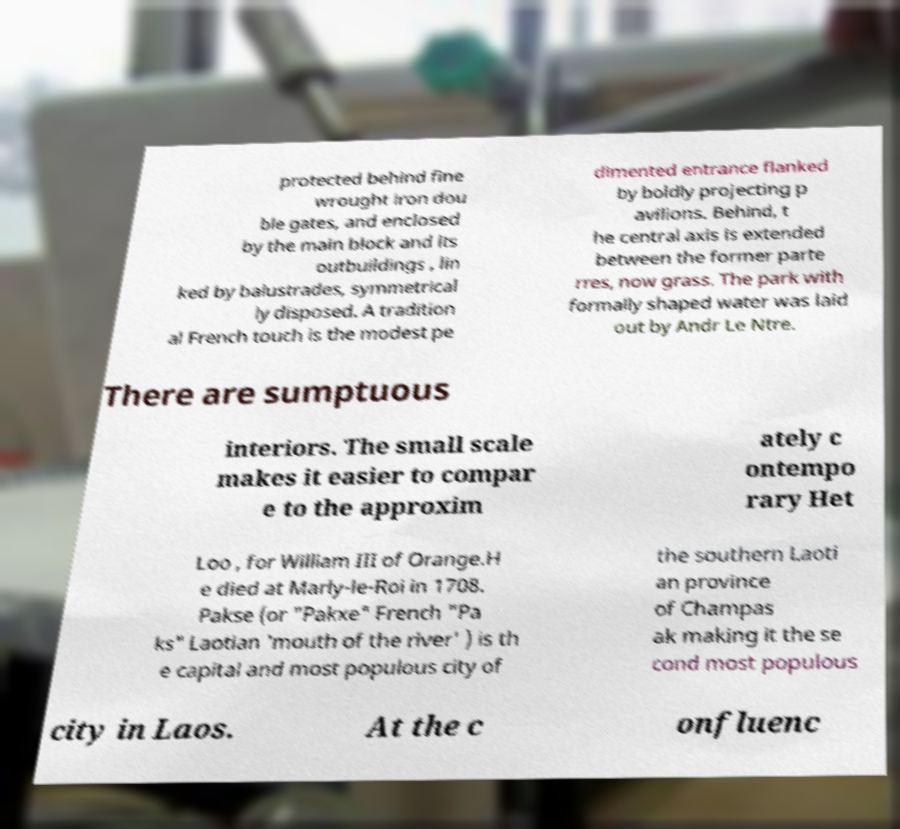Could you assist in decoding the text presented in this image and type it out clearly? protected behind fine wrought iron dou ble gates, and enclosed by the main block and its outbuildings , lin ked by balustrades, symmetrical ly disposed. A tradition al French touch is the modest pe dimented entrance flanked by boldly projecting p avilions. Behind, t he central axis is extended between the former parte rres, now grass. The park with formally shaped water was laid out by Andr Le Ntre. There are sumptuous interiors. The small scale makes it easier to compar e to the approxim ately c ontempo rary Het Loo , for William III of Orange.H e died at Marly-le-Roi in 1708. Pakse (or "Pakxe" French "Pa ks" Laotian 'mouth of the river' ) is th e capital and most populous city of the southern Laoti an province of Champas ak making it the se cond most populous city in Laos. At the c onfluenc 